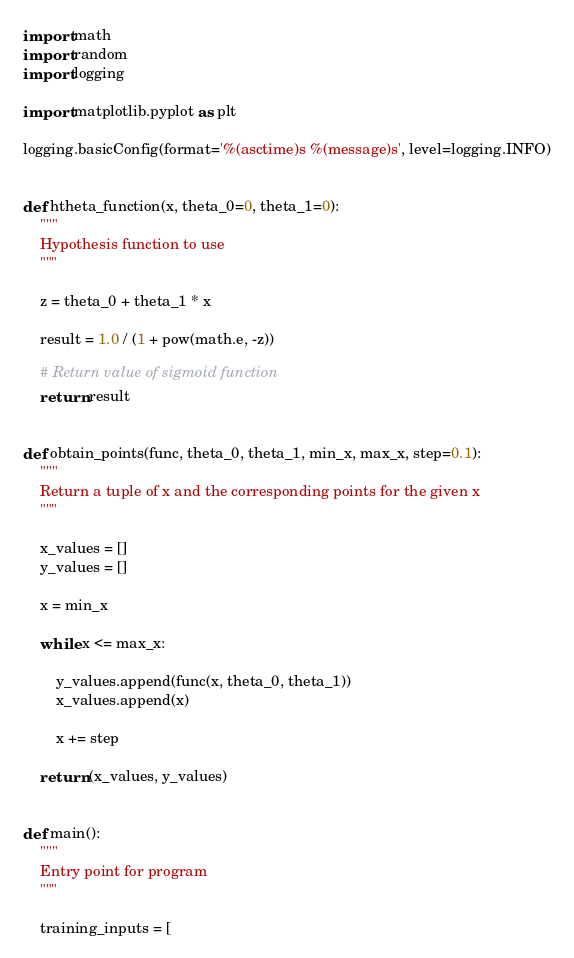<code> <loc_0><loc_0><loc_500><loc_500><_Python_>import math
import random
import logging

import matplotlib.pyplot as plt

logging.basicConfig(format='%(asctime)s %(message)s', level=logging.INFO)


def htheta_function(x, theta_0=0, theta_1=0):
    """
    Hypothesis function to use
    """

    z = theta_0 + theta_1 * x

    result = 1.0 / (1 + pow(math.e, -z))

    # Return value of sigmoid function
    return result


def obtain_points(func, theta_0, theta_1, min_x, max_x, step=0.1):
    """
    Return a tuple of x and the corresponding points for the given x
    """

    x_values = []
    y_values = []

    x = min_x

    while x <= max_x:

        y_values.append(func(x, theta_0, theta_1))
        x_values.append(x)

        x += step

    return (x_values, y_values)


def main():
    """
    Entry point for program
    """

    training_inputs = [</code> 